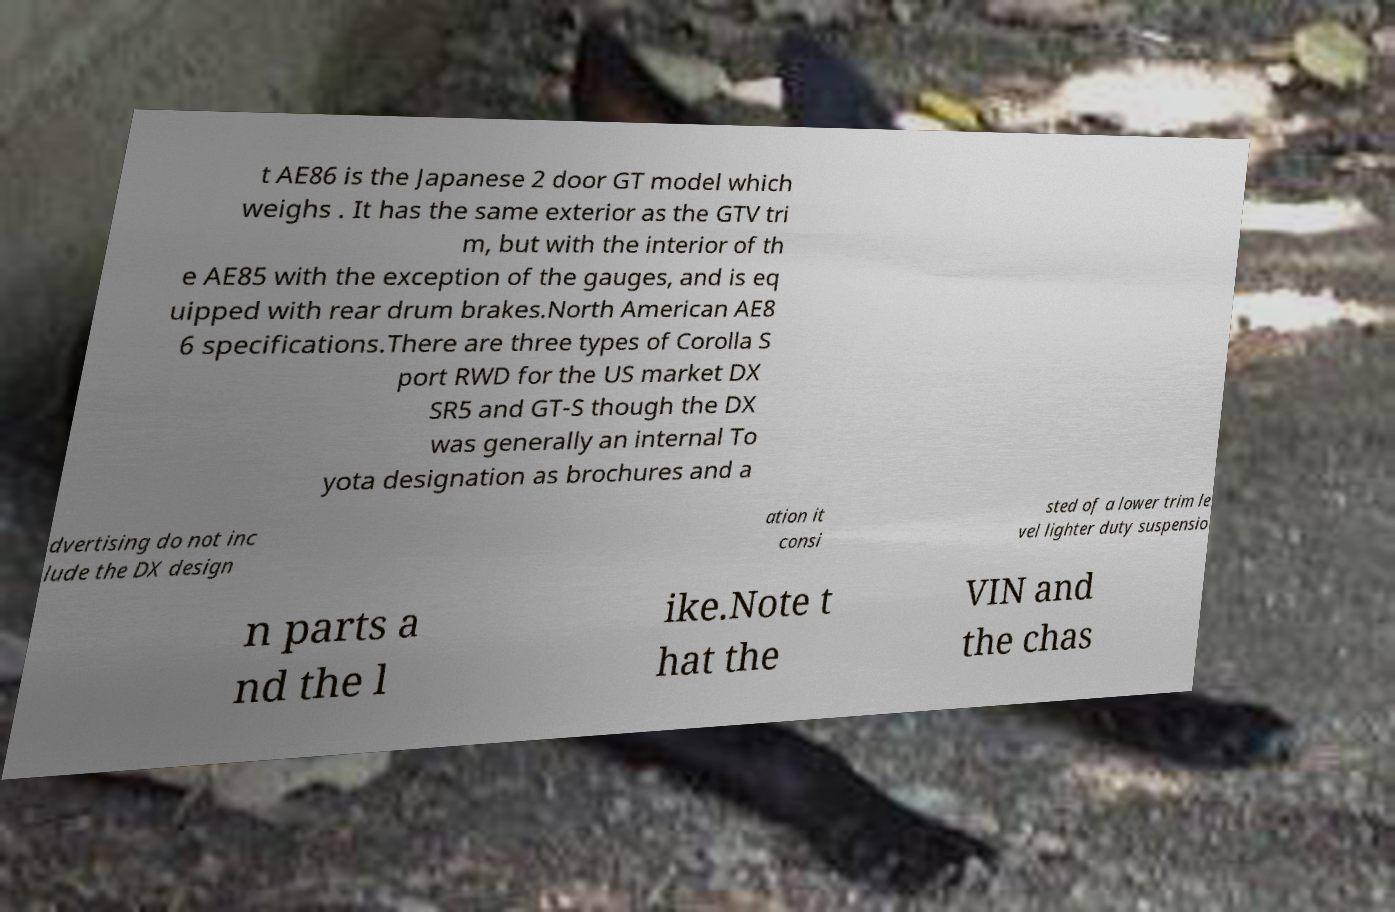Can you read and provide the text displayed in the image?This photo seems to have some interesting text. Can you extract and type it out for me? t AE86 is the Japanese 2 door GT model which weighs . It has the same exterior as the GTV tri m, but with the interior of th e AE85 with the exception of the gauges, and is eq uipped with rear drum brakes.North American AE8 6 specifications.There are three types of Corolla S port RWD for the US market DX SR5 and GT-S though the DX was generally an internal To yota designation as brochures and a dvertising do not inc lude the DX design ation it consi sted of a lower trim le vel lighter duty suspensio n parts a nd the l ike.Note t hat the VIN and the chas 